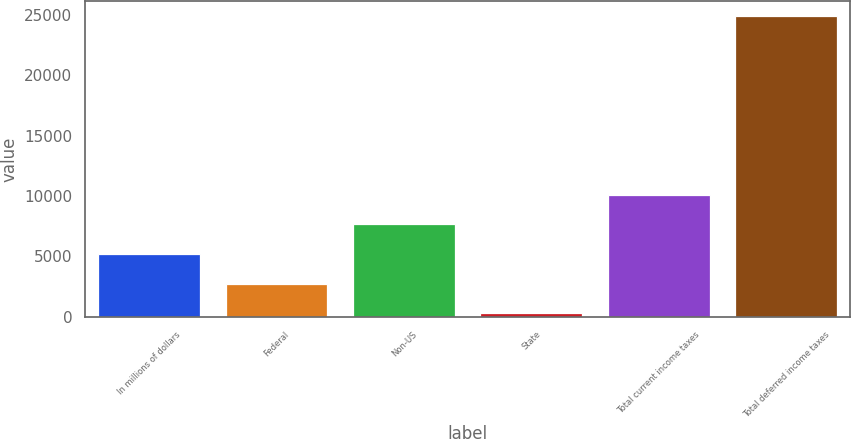Convert chart to OTSL. <chart><loc_0><loc_0><loc_500><loc_500><bar_chart><fcel>In millions of dollars<fcel>Federal<fcel>Non-US<fcel>State<fcel>Total current income taxes<fcel>Total deferred income taxes<nl><fcel>5190.6<fcel>2729.8<fcel>7651.4<fcel>269<fcel>10112.2<fcel>24877<nl></chart> 